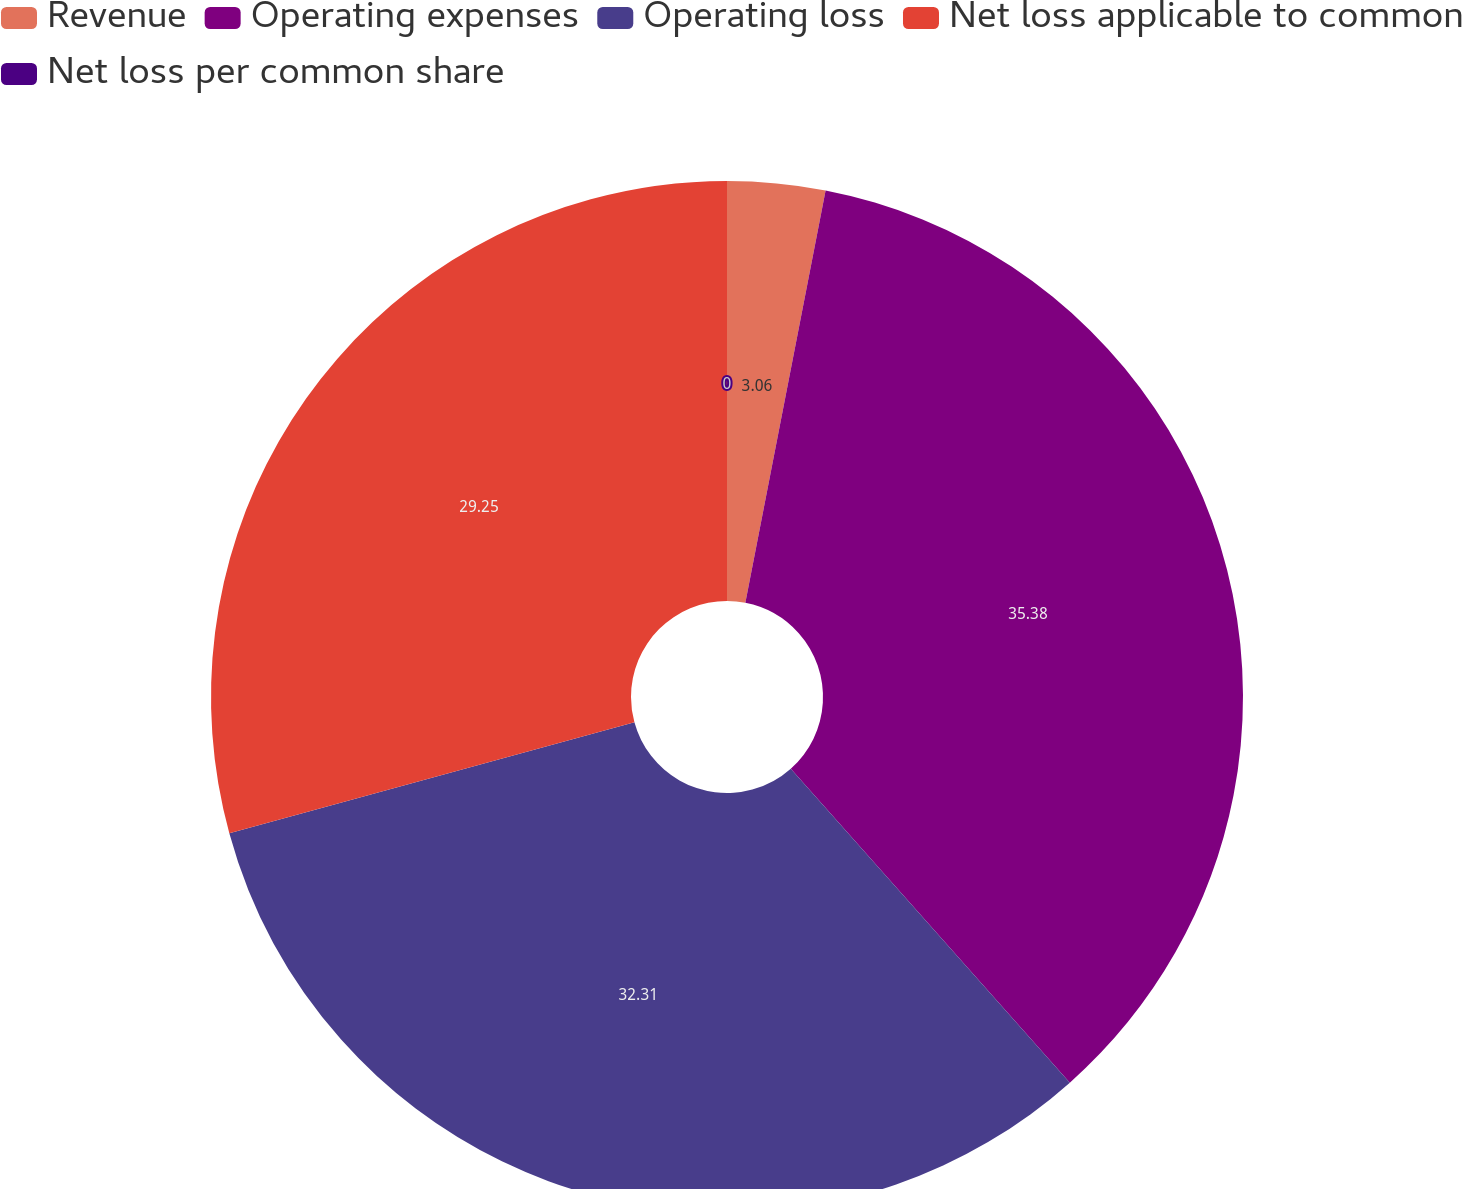Convert chart to OTSL. <chart><loc_0><loc_0><loc_500><loc_500><pie_chart><fcel>Revenue<fcel>Operating expenses<fcel>Operating loss<fcel>Net loss applicable to common<fcel>Net loss per common share<nl><fcel>3.06%<fcel>35.37%<fcel>32.31%<fcel>29.25%<fcel>0.0%<nl></chart> 